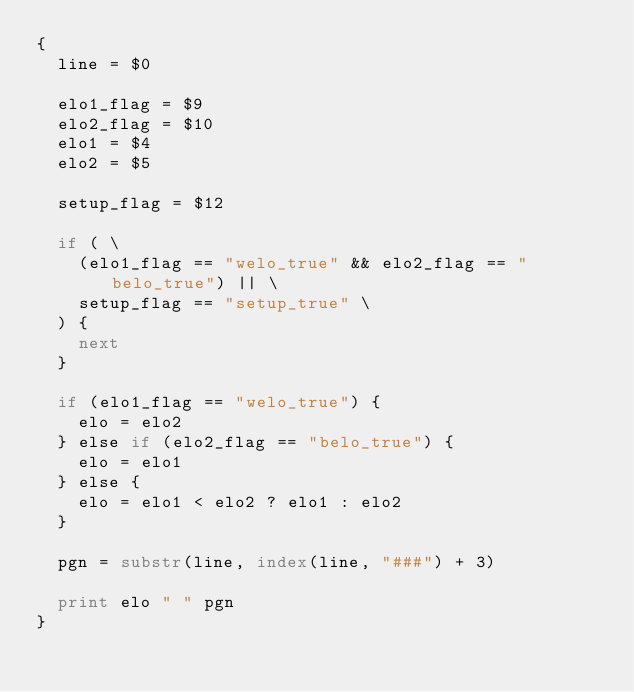<code> <loc_0><loc_0><loc_500><loc_500><_Awk_>{
	line = $0

	elo1_flag = $9
	elo2_flag = $10
	elo1 = $4
	elo2 = $5

	setup_flag = $12

	if ( \
		(elo1_flag == "welo_true" && elo2_flag == "belo_true") || \
		setup_flag == "setup_true" \
	) {
		next
	}

	if (elo1_flag == "welo_true") {
		elo = elo2
	} else if (elo2_flag == "belo_true") {
		elo = elo1
	} else {
		elo = elo1 < elo2 ? elo1 : elo2
	}

	pgn = substr(line, index(line, "###") + 3)

	print elo " " pgn
}
</code> 